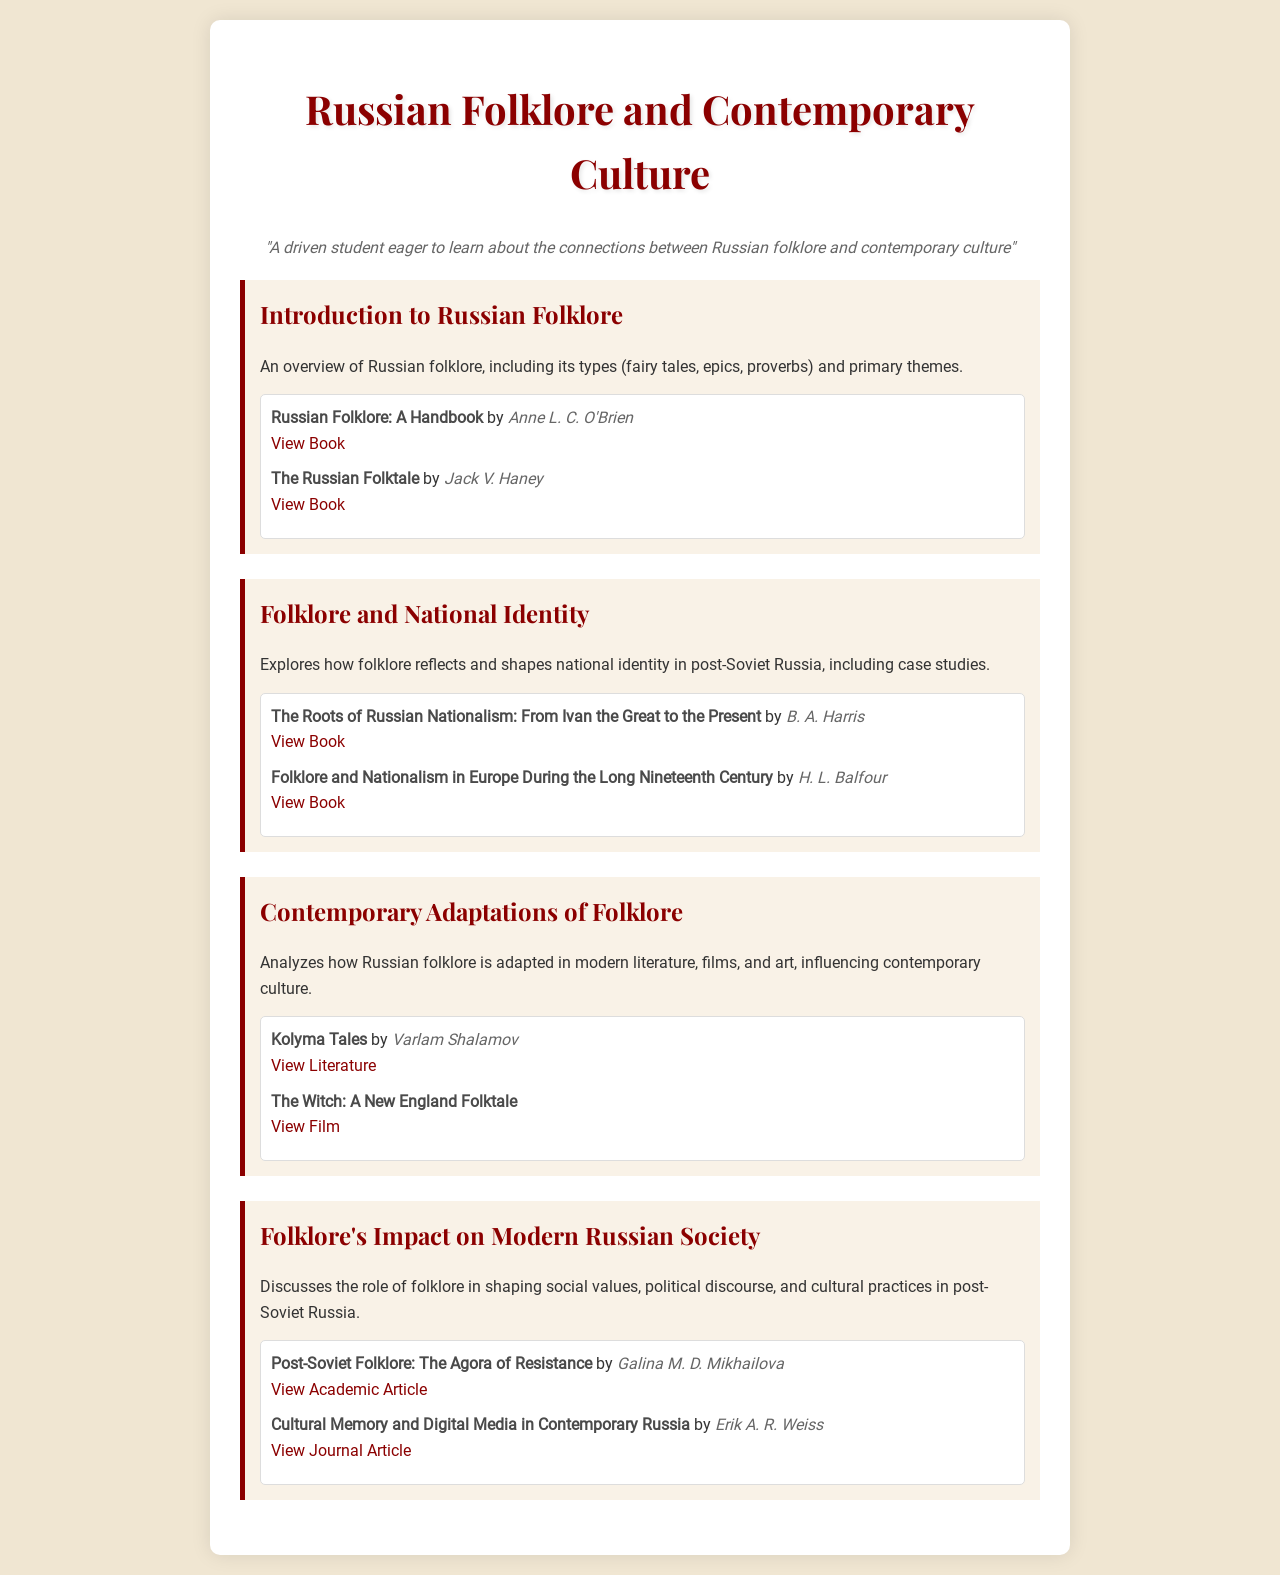What is the title of the document? The title of the document is displayed prominently at the top of the rendered schedule.
Answer: Russian Folklore and Contemporary Culture Who authored "Russian Folklore: A Handbook"? This information is found in the resources section under the introduction topic.
Answer: Anne L. C. O'Brien What is a primary theme discussed in the introduction? The introduction covers types of folklore, but the themes are implied as part of the overview.
Answer: Types of folklore Which resource discusses "The Roots of Russian Nationalism"? This can be found in the resources of the second topic regarding folklore and national identity.
Answer: The Roots of Russian Nationalism: From Ivan the Great to the Present What type of media is analyzed in relation to contemporary folklore adaptations? The document specifically highlights adaptations in various forms of media linked to folklore.
Answer: Literature, films, and art Who wrote "Post-Soviet Folklore: The Agora of Resistance"? This information is in the resources section of the last topic regarding folklore's impact on society.
Answer: Galina M. D. Mikhailova 